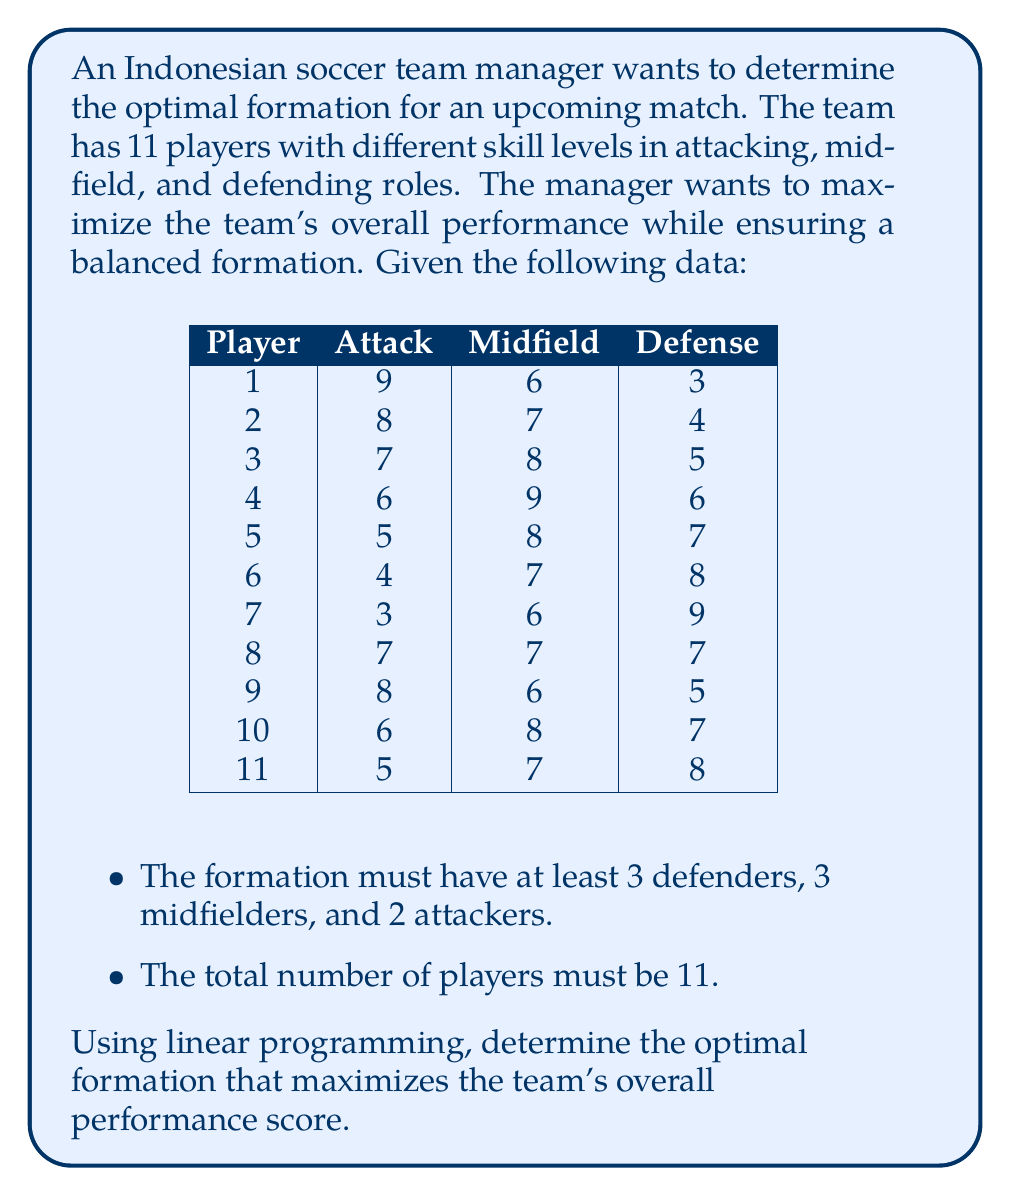Can you answer this question? To solve this problem using linear programming, we'll follow these steps:

1. Define the decision variables:
   Let $x_i$, $y_i$, and $z_i$ be binary variables indicating whether player $i$ is assigned to attack, midfield, or defense, respectively.

2. Set up the objective function:
   Maximize the total performance score:
   $$\text{Max } Z = \sum_{i=1}^{11} (9x_1 + 8x_2 + 7x_3 + 6x_4 + 5x_5 + 4x_6 + 3x_7 + 7x_8 + 8x_9 + 6x_{10} + 5x_{11}) +$$
   $$(6y_1 + 7y_2 + 8y_3 + 9y_4 + 8y_5 + 7y_6 + 6y_7 + 7y_8 + 6y_9 + 8y_{10} + 7y_{11}) +$$
   $$(3z_1 + 4z_2 + 5z_3 + 6z_4 + 7z_5 + 8z_6 + 9z_7 + 7z_8 + 5z_9 + 7z_{10} + 8z_{11})$$

3. Define the constraints:
   a) Each player can only be assigned to one position:
      $$x_i + y_i + z_i = 1 \text{ for } i = 1, 2, ..., 11$$
   
   b) Total number of players must be 11:
      $$\sum_{i=1}^{11} (x_i + y_i + z_i) = 11$$
   
   c) Minimum number of players in each position:
      $$\sum_{i=1}^{11} x_i \geq 2 \text{ (attackers)}$$
      $$\sum_{i=1}^{11} y_i \geq 3 \text{ (midfielders)}$$
      $$\sum_{i=1}^{11} z_i \geq 3 \text{ (defenders)}$$

4. Solve the linear programming problem using a solver (e.g., simplex method).

5. Interpret the results:
   The optimal solution will assign players to positions that maximize the overall performance score while satisfying all constraints.

6. Determine the formation:
   Count the number of players in each position to get the optimal formation (e.g., 3-5-2, 4-4-2, etc.).
Answer: 4-4-3 formation 